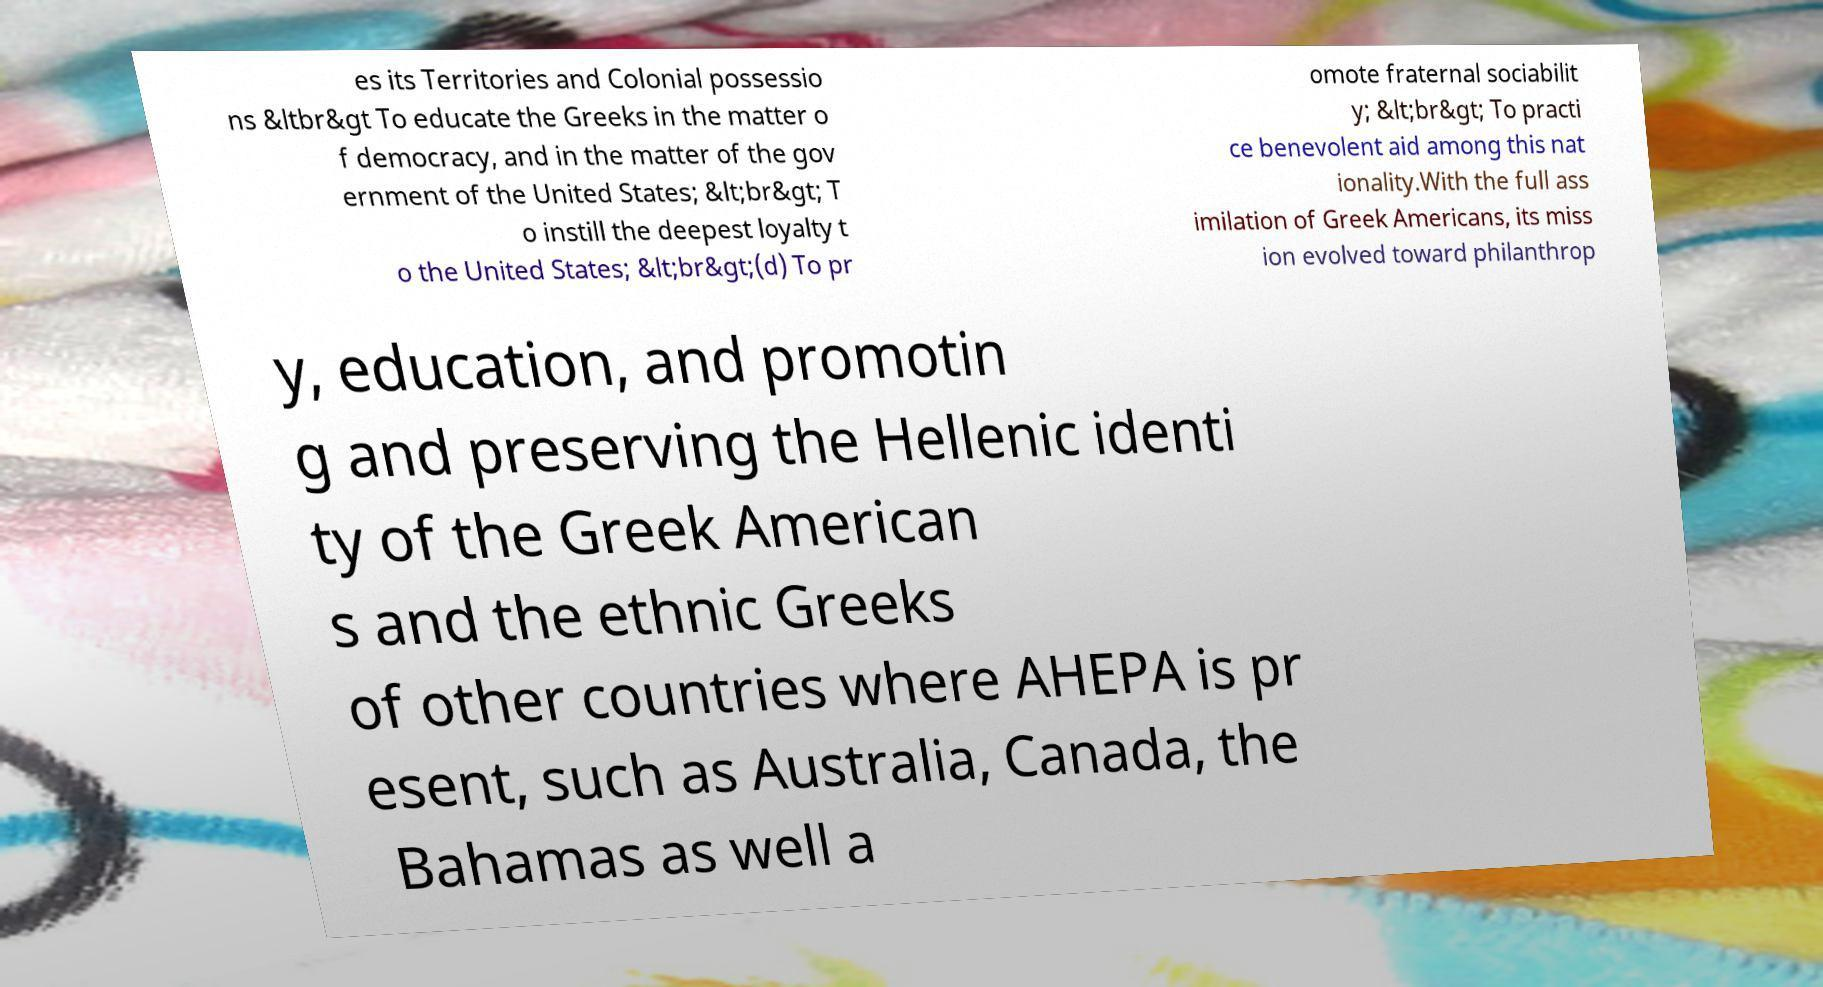There's text embedded in this image that I need extracted. Can you transcribe it verbatim? es its Territories and Colonial possessio ns &ltbr&gt To educate the Greeks in the matter o f democracy, and in the matter of the gov ernment of the United States; &lt;br&gt; T o instill the deepest loyalty t o the United States; &lt;br&gt;(d) To pr omote fraternal sociabilit y; &lt;br&gt; To practi ce benevolent aid among this nat ionality.With the full ass imilation of Greek Americans, its miss ion evolved toward philanthrop y, education, and promotin g and preserving the Hellenic identi ty of the Greek American s and the ethnic Greeks of other countries where AHEPA is pr esent, such as Australia, Canada, the Bahamas as well a 